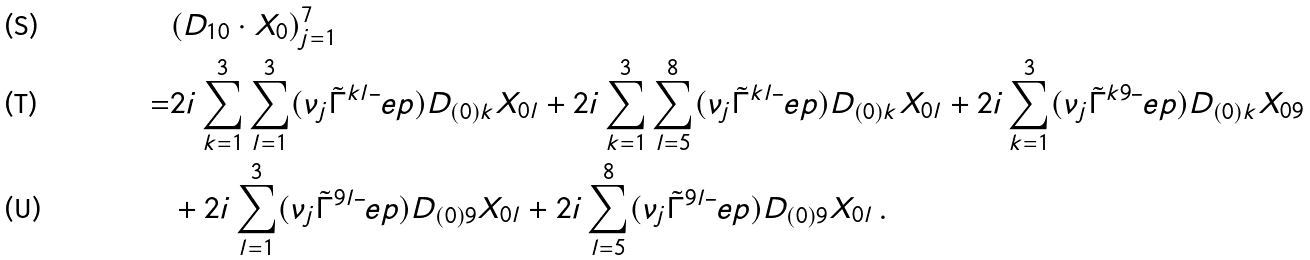<formula> <loc_0><loc_0><loc_500><loc_500>& ( D _ { 1 0 } \cdot X _ { 0 } ) _ { j = 1 } ^ { 7 } \\ = & 2 i \sum _ { k = 1 } ^ { 3 } \sum _ { l = 1 } ^ { 3 } ( \nu _ { j } \tilde { \Gamma } ^ { k l } \bar { \ } e p ) D _ { ( 0 ) k } X _ { 0 l } + 2 i \sum _ { k = 1 } ^ { 3 } \sum _ { l = 5 } ^ { 8 } ( \nu _ { j } \tilde { \Gamma } ^ { k l } \bar { \ } e p ) D _ { ( 0 ) k } X _ { 0 l } + 2 i \sum _ { k = 1 } ^ { 3 } ( \nu _ { j } \tilde { \Gamma } ^ { k 9 } \bar { \ } e p ) D _ { ( 0 ) k } X _ { 0 9 } \\ & + 2 i \sum _ { l = 1 } ^ { 3 } ( \nu _ { j } \tilde { \Gamma } ^ { 9 l } \bar { \ } e p ) D _ { ( 0 ) 9 } X _ { 0 l } + 2 i \sum _ { l = 5 } ^ { 8 } ( \nu _ { j } \tilde { \Gamma } ^ { 9 l } \bar { \ } e p ) D _ { ( 0 ) 9 } X _ { 0 l } \, .</formula> 